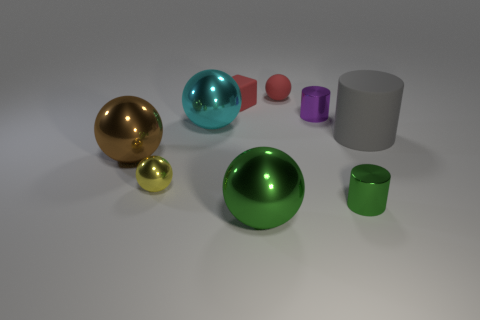Subtract all cyan balls. How many balls are left? 4 Subtract all large brown metal spheres. How many spheres are left? 4 Subtract all gray spheres. Subtract all purple cubes. How many spheres are left? 5 Add 1 small purple matte cylinders. How many objects exist? 10 Subtract all cylinders. How many objects are left? 6 Add 5 red blocks. How many red blocks are left? 6 Add 9 red spheres. How many red spheres exist? 10 Subtract 1 green spheres. How many objects are left? 8 Subtract all large brown metal objects. Subtract all tiny yellow objects. How many objects are left? 7 